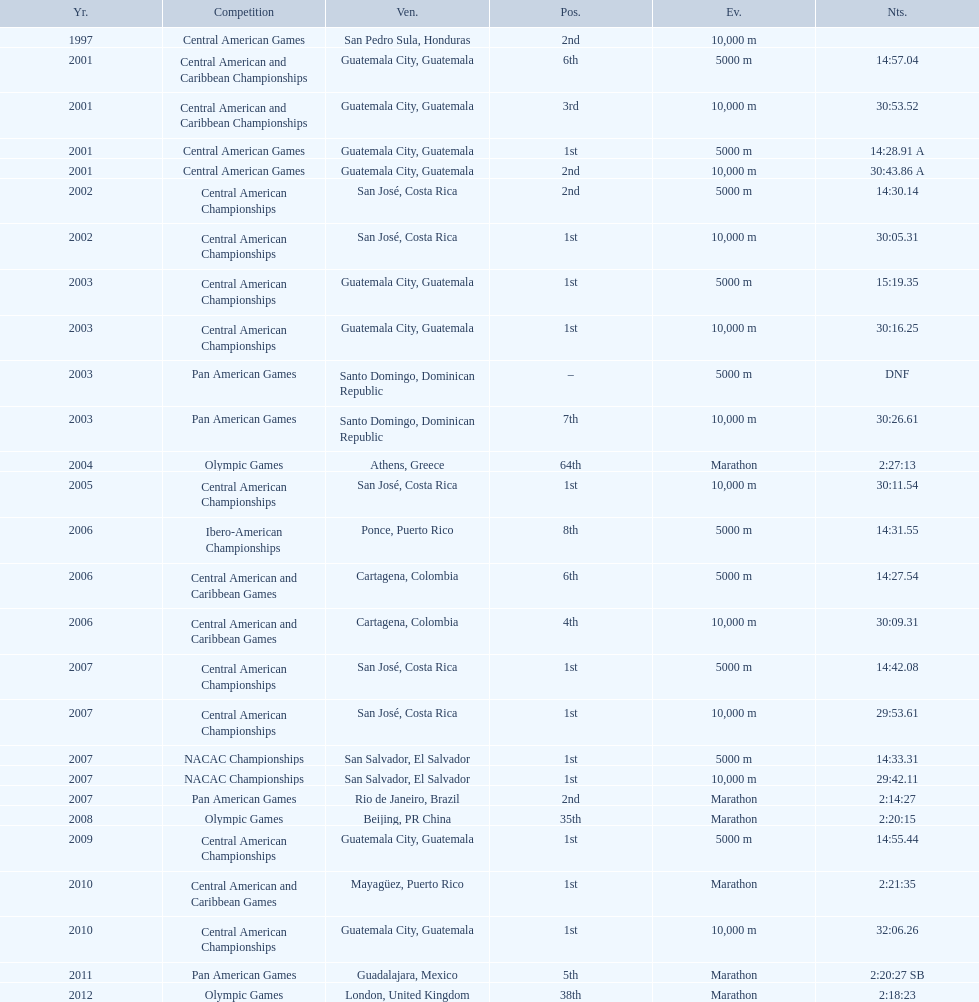Which of each game in 2007 was in the 2nd position? Pan American Games. 